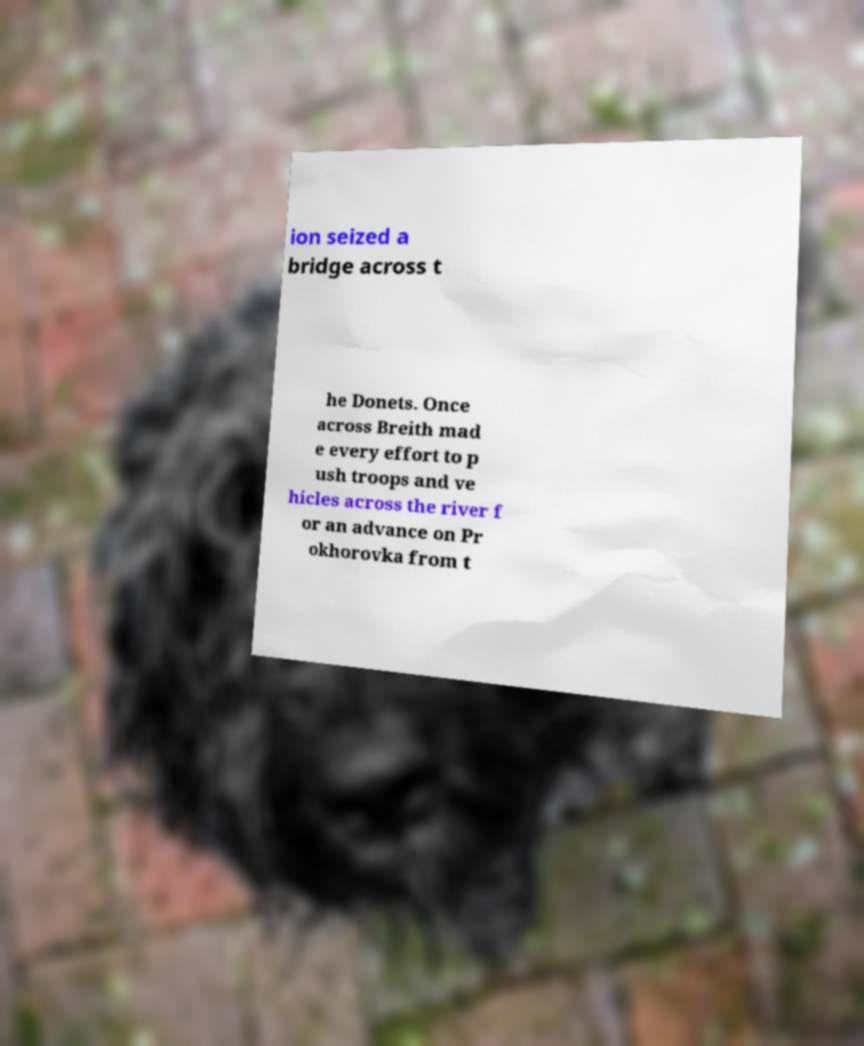Could you assist in decoding the text presented in this image and type it out clearly? ion seized a bridge across t he Donets. Once across Breith mad e every effort to p ush troops and ve hicles across the river f or an advance on Pr okhorovka from t 